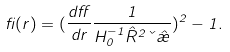<formula> <loc_0><loc_0><loc_500><loc_500>\beta ( r ) = ( \frac { d \alpha } { d r } \frac { 1 } { H ^ { - 1 } _ { 0 } \hat { R } ^ { 2 } \kappa \hat { \rho } } ) ^ { 2 } - 1 .</formula> 